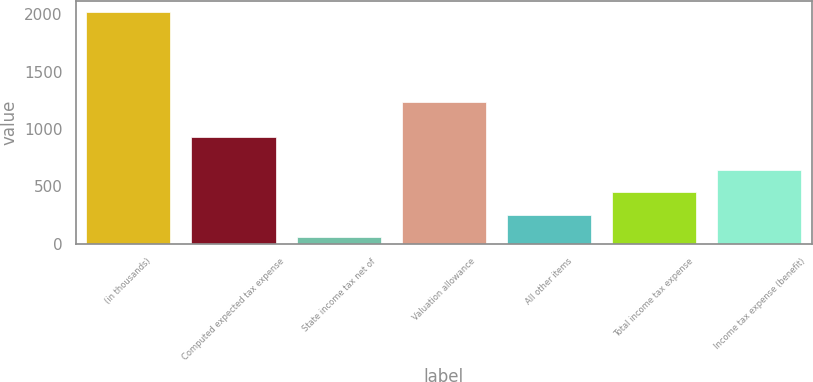<chart> <loc_0><loc_0><loc_500><loc_500><bar_chart><fcel>(in thousands)<fcel>Computed expected tax expense<fcel>State income tax net of<fcel>Valuation allowance<fcel>All other items<fcel>Total income tax expense<fcel>Income tax expense (benefit)<nl><fcel>2016<fcel>933<fcel>56<fcel>1239<fcel>252<fcel>448<fcel>644<nl></chart> 